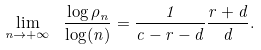Convert formula to latex. <formula><loc_0><loc_0><loc_500><loc_500>\lim _ { n \rightarrow + \infty } \ \frac { \log \rho _ { n } } { \log ( n ) } = \frac { 1 } { c - r - d } \frac { r + d } { d } .</formula> 